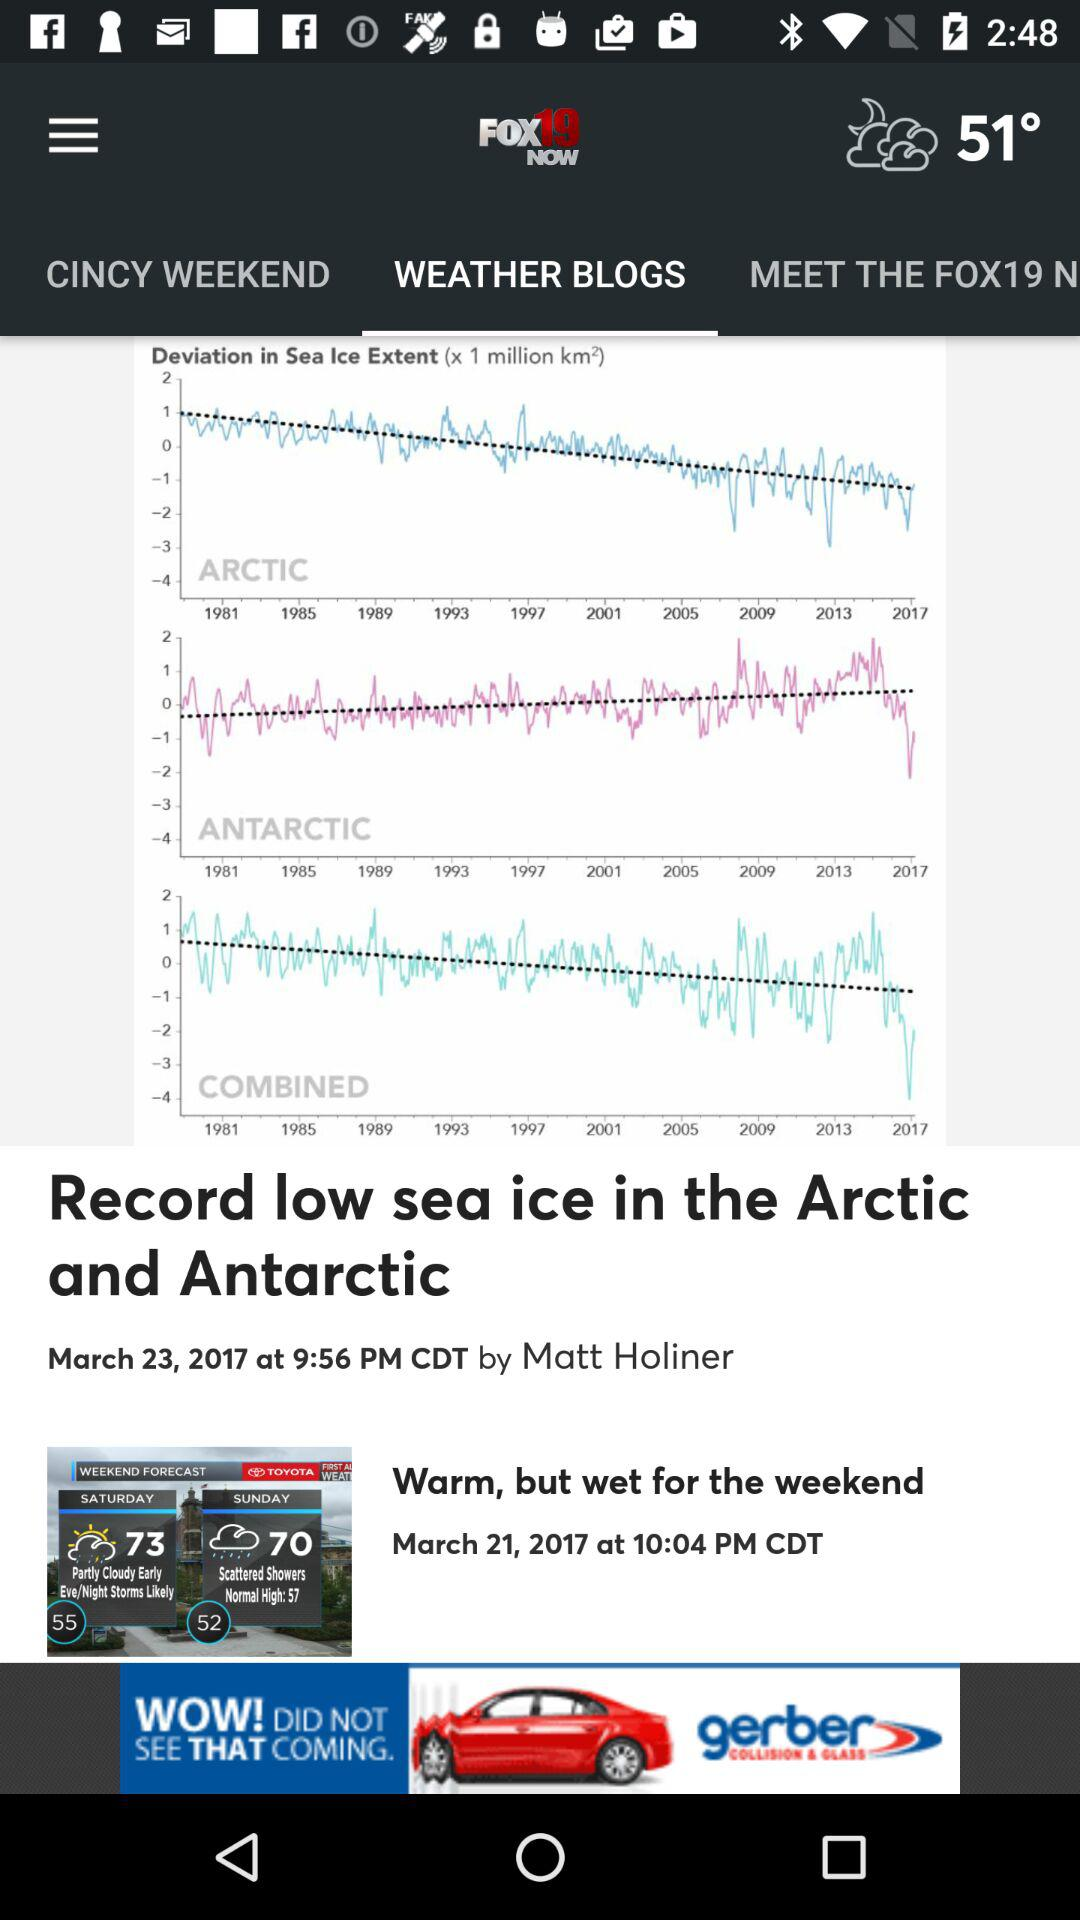What is the ice level on March 23, 2017? The sea ice level is low. 